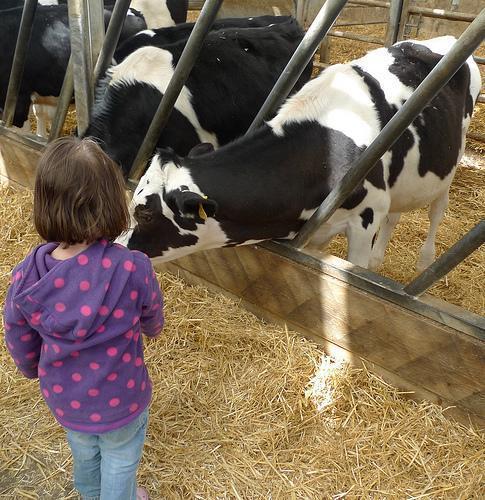How many cows are there?
Give a very brief answer. 3. 